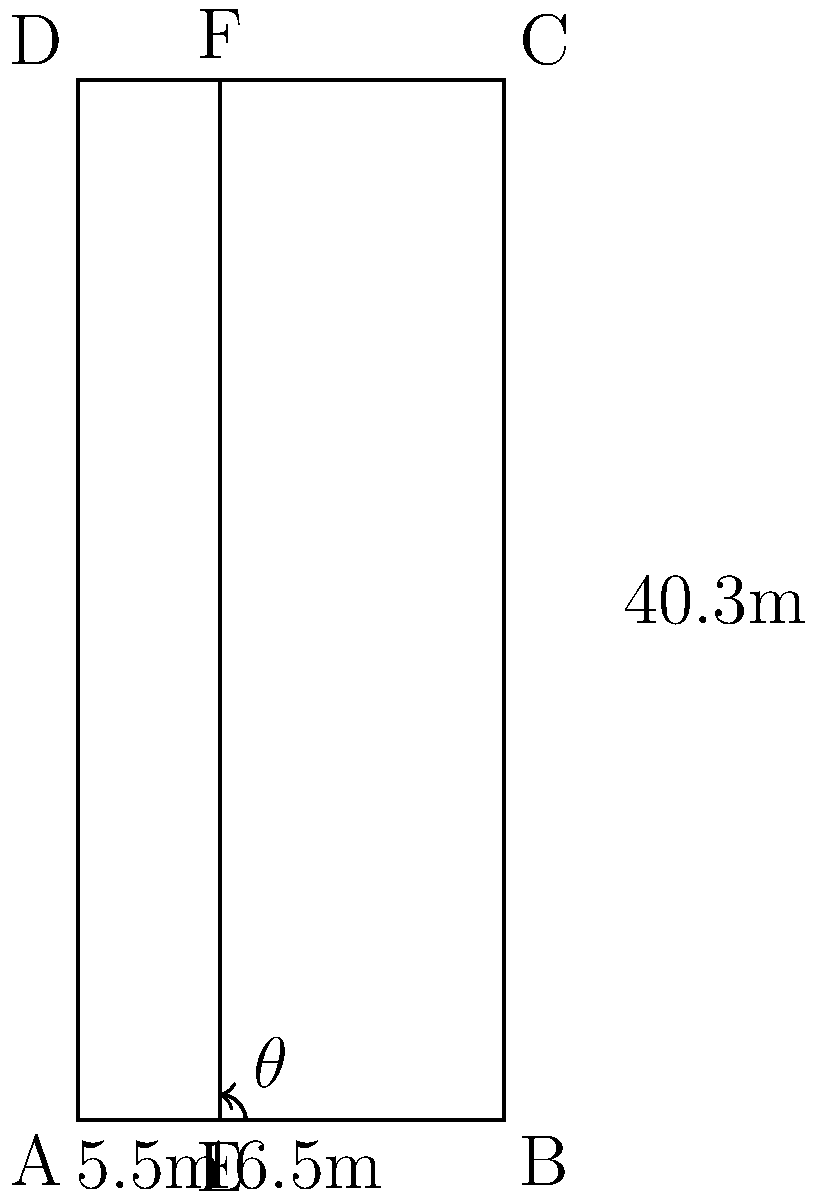In your local soccer league, you've been tasked with calculating the area of the penalty box. The penalty box is rectangular, with dimensions 16.5m wide and 40.3m long. There's also a smaller rectangle within it, 5.5m from the goal line. If the angle between the goal line and the line from the corner of the penalty box to the near post of the goal is $\theta$, calculate the area of the penalty box using trigonometric ratios. Let's approach this step-by-step:

1) First, we need to find $\theta$. We can do this using the tangent ratio:

   $\tan \theta = \frac{\text{opposite}}{\text{adjacent}} = \frac{40.3}{5.5}$

2) Now we can calculate $\theta$:

   $\theta = \arctan(\frac{40.3}{5.5}) \approx 82.23°$

3) However, we don't actually need $\theta$ to calculate the area. The penalty box is a rectangle, so we can simply multiply its length by its width:

   Area $= 16.5 \text{ m} \times 40.3 \text{ m} = 665.95 \text{ m}^2$

4) While we didn't use $\theta$ in our final calculation, understanding how to find it using trigonometric ratios is crucial for more complex field calculations you might encounter in soccer analytics.
Answer: $665.95 \text{ m}^2$ 